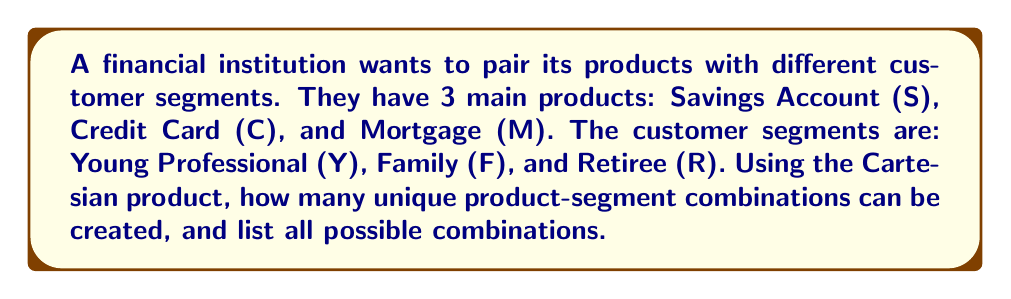What is the answer to this math problem? To solve this problem, we'll use the concept of Cartesian product from set theory.

1. Define the sets:
   Products: $P = \{S, C, M\}$
   Customer Segments: $Q = \{Y, F, R\}$

2. The Cartesian product of these sets is defined as:
   $P \times Q = \{(p, q) | p \in P \text{ and } q \in Q\}$

3. To find the number of combinations:
   $|P \times Q| = |P| \times |Q|$
   Where $|P|$ is the number of elements in set $P$ and $|Q|$ is the number of elements in set $Q$.

   $|P \times Q| = 3 \times 3 = 9$

4. To list all possible combinations, we pair each element from $P$ with each element from $Q$:

   $P \times Q = \{(S,Y), (S,F), (S,R), (C,Y), (C,F), (C,R), (M,Y), (M,F), (M,R)\}$

Each pair represents a unique product-segment combination, which can be used to tailor marketing strategies or develop specific financial offerings for each customer segment.
Answer: There are 9 unique product-segment combinations:
$P \times Q = \{(S,Y), (S,F), (S,R), (C,Y), (C,F), (C,R), (M,Y), (M,F), (M,R)\}$ 